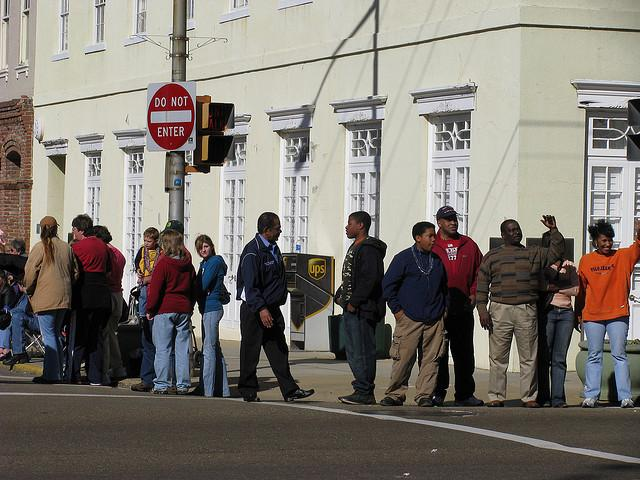What is under the red and white sign? Please explain your reasoning. boy. A child is standing under a stop sign on a sidewalk. 